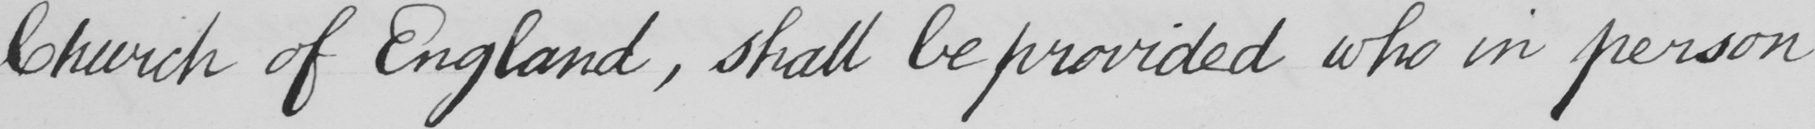What does this handwritten line say? Church of England , shall be provided who in person 